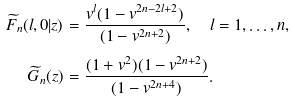Convert formula to latex. <formula><loc_0><loc_0><loc_500><loc_500>\widetilde { F } _ { n } ( l , 0 | z ) & = \frac { v ^ { l } ( 1 - v ^ { 2 n - 2 l + 2 } ) } { ( 1 - v ^ { 2 n + 2 } ) } , \quad l = 1 , \dots , n , \\ \widetilde { G } _ { n } ( z ) & = \frac { ( 1 + v ^ { 2 } ) ( 1 - v ^ { 2 n + 2 } ) } { ( 1 - v ^ { 2 n + 4 } ) } .</formula> 